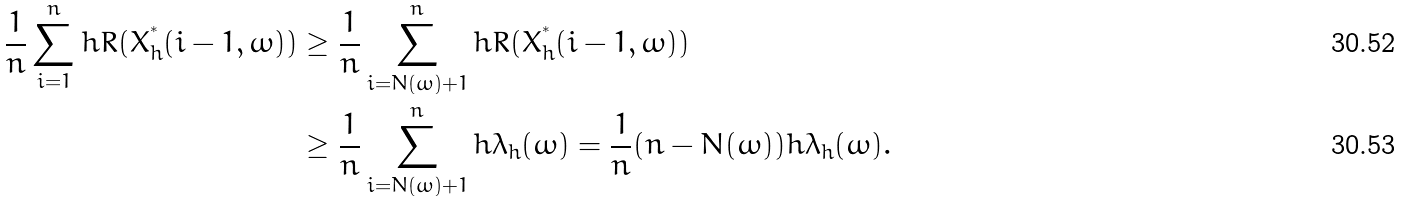<formula> <loc_0><loc_0><loc_500><loc_500>\frac { 1 } { n } \sum _ { i = 1 } ^ { n } h R ( X _ { h } ^ { ^ { * } } ( i - 1 , \omega ) ) & \geq \frac { 1 } { n } \sum _ { i = N ( \omega ) + 1 } ^ { n } h R ( X _ { h } ^ { ^ { * } } ( i - 1 , \omega ) ) \\ & \geq \frac { 1 } { n } \sum _ { i = N ( \omega ) + 1 } ^ { n } h \lambda _ { h } ( \omega ) = \frac { 1 } { n } ( n - N ( \omega ) ) h \lambda _ { h } ( \omega ) .</formula> 